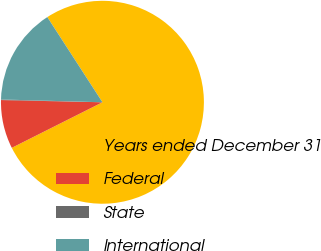<chart> <loc_0><loc_0><loc_500><loc_500><pie_chart><fcel>Years ended December 31<fcel>Federal<fcel>State<fcel>International<nl><fcel>76.73%<fcel>7.76%<fcel>0.09%<fcel>15.42%<nl></chart> 